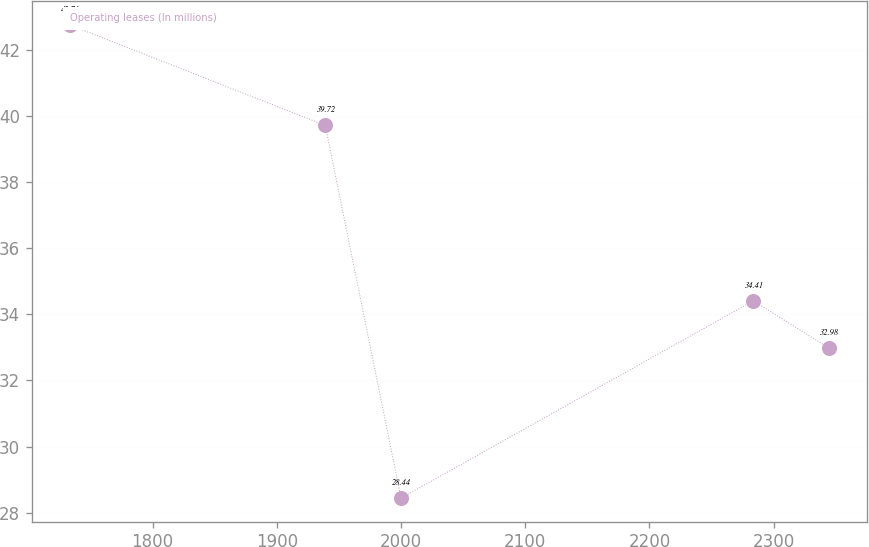<chart> <loc_0><loc_0><loc_500><loc_500><line_chart><ecel><fcel>Operating leases (In millions)<nl><fcel>1733.35<fcel>42.76<nl><fcel>1938.95<fcel>39.72<nl><fcel>2000.03<fcel>28.44<nl><fcel>2283.58<fcel>34.41<nl><fcel>2344.66<fcel>32.98<nl></chart> 